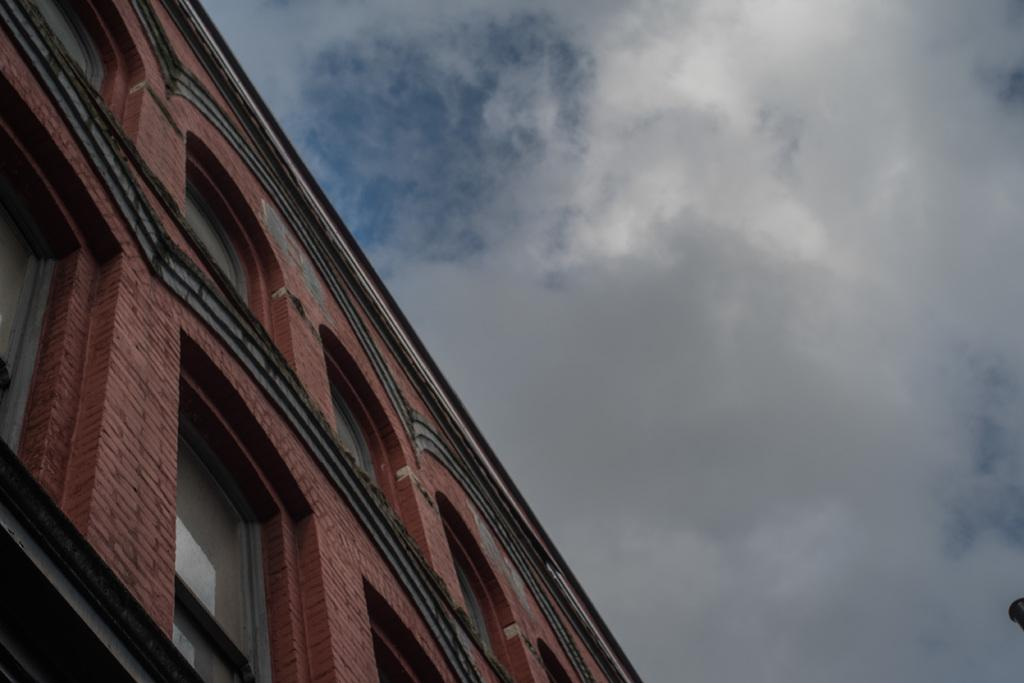What is the color of the building in the picture? The building in the picture is red. What feature of the building is mentioned in the facts? The building has multiple windows. What can be seen in the background of the picture? The sky is visible in the background of the picture. How would you describe the sky in the picture? The sky appears to be cloudy. What type of steel is used to construct the building in the image? The facts provided do not mention any information about the materials used to construct the building, so we cannot determine the type of steel used. Can you see any tigers in the image? No, there are no tigers present in the image. 